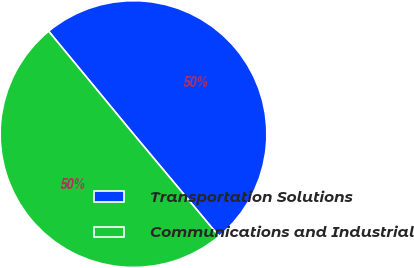<chart> <loc_0><loc_0><loc_500><loc_500><pie_chart><fcel>Transportation Solutions<fcel>Communications and Industrial<nl><fcel>49.89%<fcel>50.11%<nl></chart> 